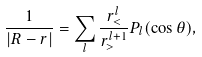Convert formula to latex. <formula><loc_0><loc_0><loc_500><loc_500>\frac { 1 } { | { R } - { r } | } = \sum _ { l } \frac { r _ { < } ^ { l } } { r _ { > } ^ { l + 1 } } P _ { l } ( \cos \theta ) ,</formula> 